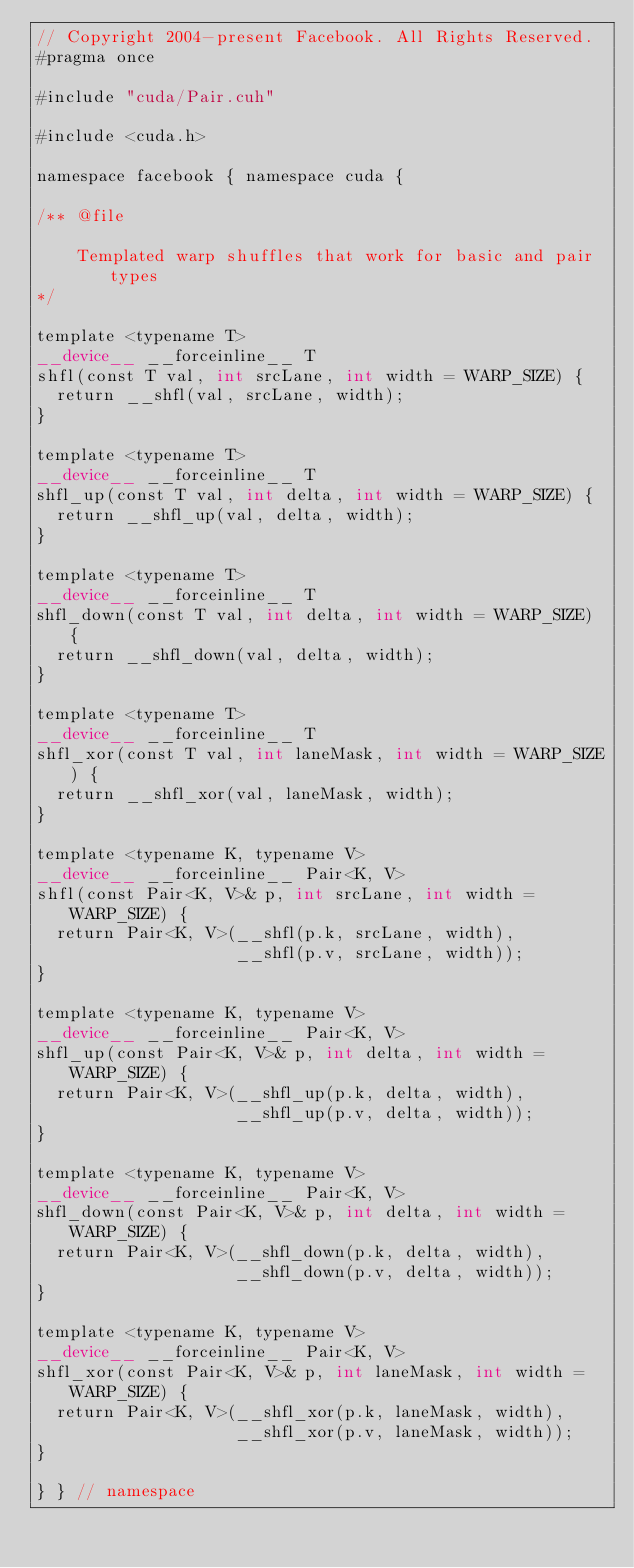Convert code to text. <code><loc_0><loc_0><loc_500><loc_500><_Cuda_>// Copyright 2004-present Facebook. All Rights Reserved.
#pragma once

#include "cuda/Pair.cuh"

#include <cuda.h>

namespace facebook { namespace cuda {

/** @file

    Templated warp shuffles that work for basic and pair types
*/

template <typename T>
__device__ __forceinline__ T
shfl(const T val, int srcLane, int width = WARP_SIZE) {
  return __shfl(val, srcLane, width);
}

template <typename T>
__device__ __forceinline__ T
shfl_up(const T val, int delta, int width = WARP_SIZE) {
  return __shfl_up(val, delta, width);
}

template <typename T>
__device__ __forceinline__ T
shfl_down(const T val, int delta, int width = WARP_SIZE) {
  return __shfl_down(val, delta, width);
}

template <typename T>
__device__ __forceinline__ T
shfl_xor(const T val, int laneMask, int width = WARP_SIZE) {
  return __shfl_xor(val, laneMask, width);
}

template <typename K, typename V>
__device__ __forceinline__ Pair<K, V>
shfl(const Pair<K, V>& p, int srcLane, int width = WARP_SIZE) {
  return Pair<K, V>(__shfl(p.k, srcLane, width),
                    __shfl(p.v, srcLane, width));
}

template <typename K, typename V>
__device__ __forceinline__ Pair<K, V>
shfl_up(const Pair<K, V>& p, int delta, int width = WARP_SIZE) {
  return Pair<K, V>(__shfl_up(p.k, delta, width),
                    __shfl_up(p.v, delta, width));
}

template <typename K, typename V>
__device__ __forceinline__ Pair<K, V>
shfl_down(const Pair<K, V>& p, int delta, int width = WARP_SIZE) {
  return Pair<K, V>(__shfl_down(p.k, delta, width),
                    __shfl_down(p.v, delta, width));
}

template <typename K, typename V>
__device__ __forceinline__ Pair<K, V>
shfl_xor(const Pair<K, V>& p, int laneMask, int width = WARP_SIZE) {
  return Pair<K, V>(__shfl_xor(p.k, laneMask, width),
                    __shfl_xor(p.v, laneMask, width));
}

} } // namespace
</code> 